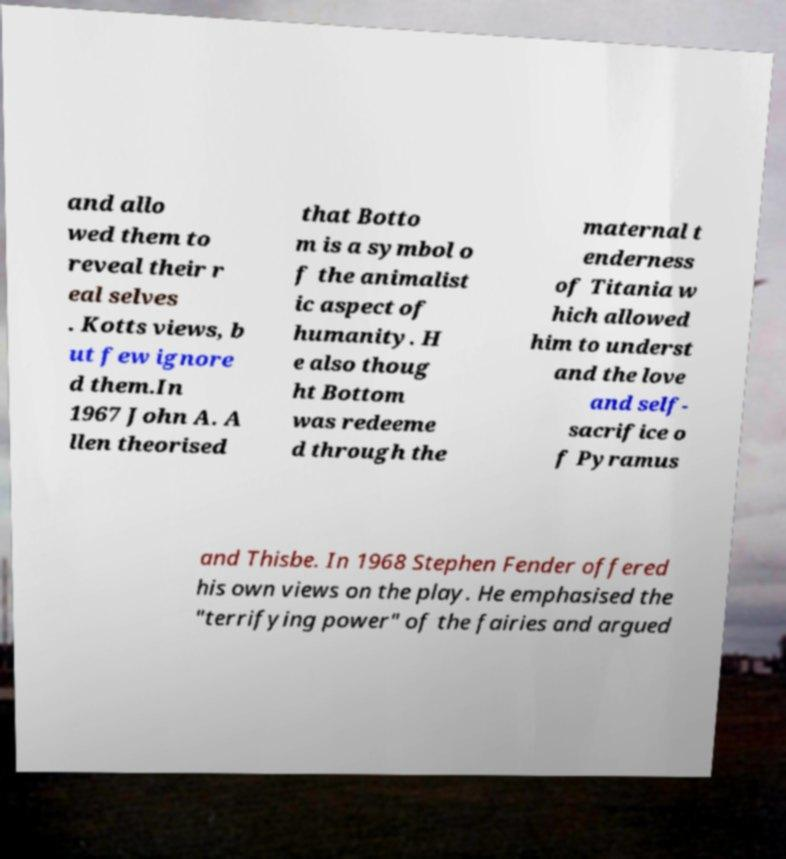For documentation purposes, I need the text within this image transcribed. Could you provide that? and allo wed them to reveal their r eal selves . Kotts views, b ut few ignore d them.In 1967 John A. A llen theorised that Botto m is a symbol o f the animalist ic aspect of humanity. H e also thoug ht Bottom was redeeme d through the maternal t enderness of Titania w hich allowed him to underst and the love and self- sacrifice o f Pyramus and Thisbe. In 1968 Stephen Fender offered his own views on the play. He emphasised the "terrifying power" of the fairies and argued 